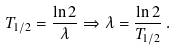<formula> <loc_0><loc_0><loc_500><loc_500>T _ { 1 / 2 } = \frac { \ln 2 } { \lambda } \Rightarrow \lambda = \frac { \ln 2 } { T _ { 1 / 2 } } \, .</formula> 